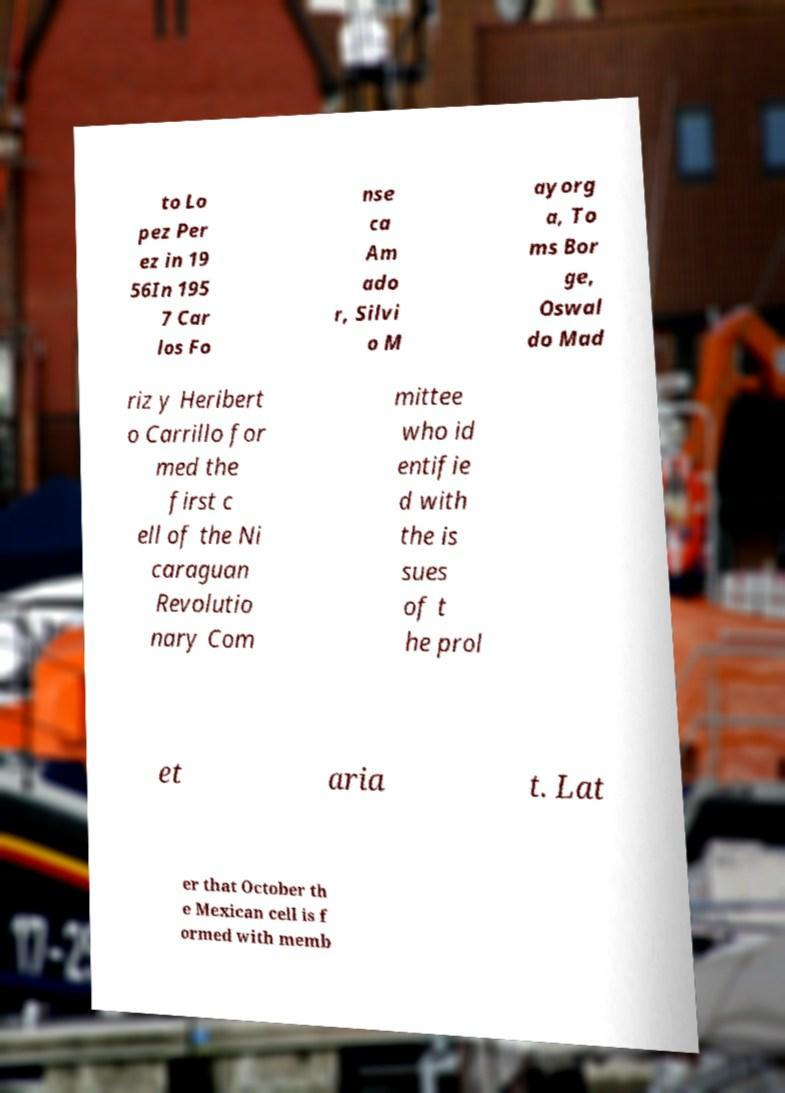Please read and relay the text visible in this image. What does it say? to Lo pez Per ez in 19 56In 195 7 Car los Fo nse ca Am ado r, Silvi o M ayorg a, To ms Bor ge, Oswal do Mad riz y Heribert o Carrillo for med the first c ell of the Ni caraguan Revolutio nary Com mittee who id entifie d with the is sues of t he prol et aria t. Lat er that October th e Mexican cell is f ormed with memb 